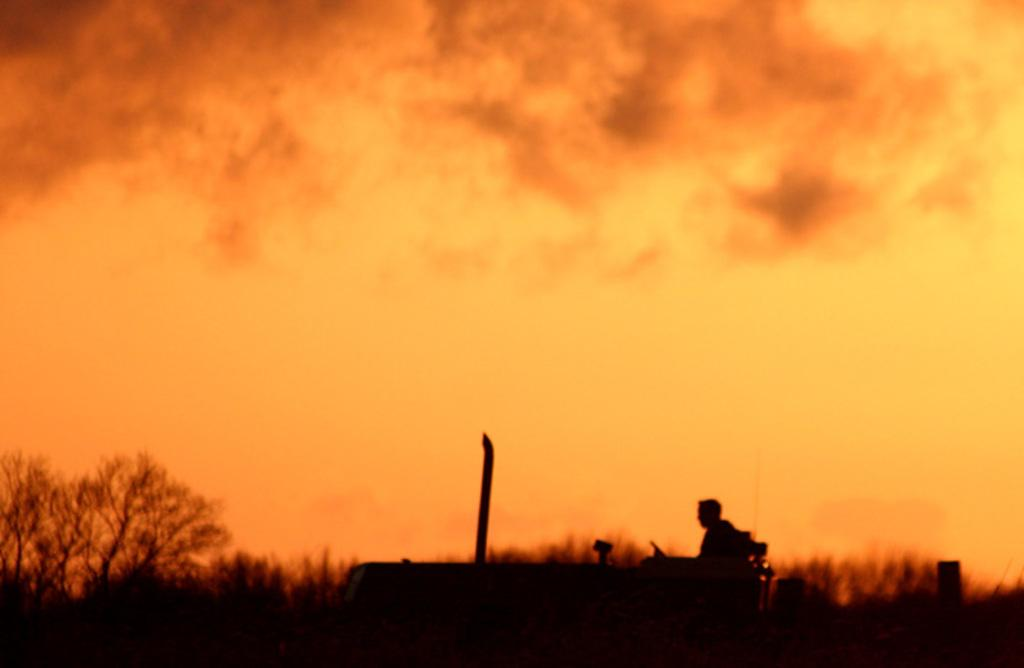What is the person in the image doing? The person is sitting on a seat and driving a tractor. Where is the tractor located in the image? The tractor is on a road. What can be seen in the background of the image? There are trees in the background of the image. What is visible in the sky in the image? There are clouds in the sky. What mass of water is present in the image? There is no water present in the image, as it features a person driving a tractor on a road with trees and clouds in the background. 